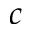Convert formula to latex. <formula><loc_0><loc_0><loc_500><loc_500>c</formula> 